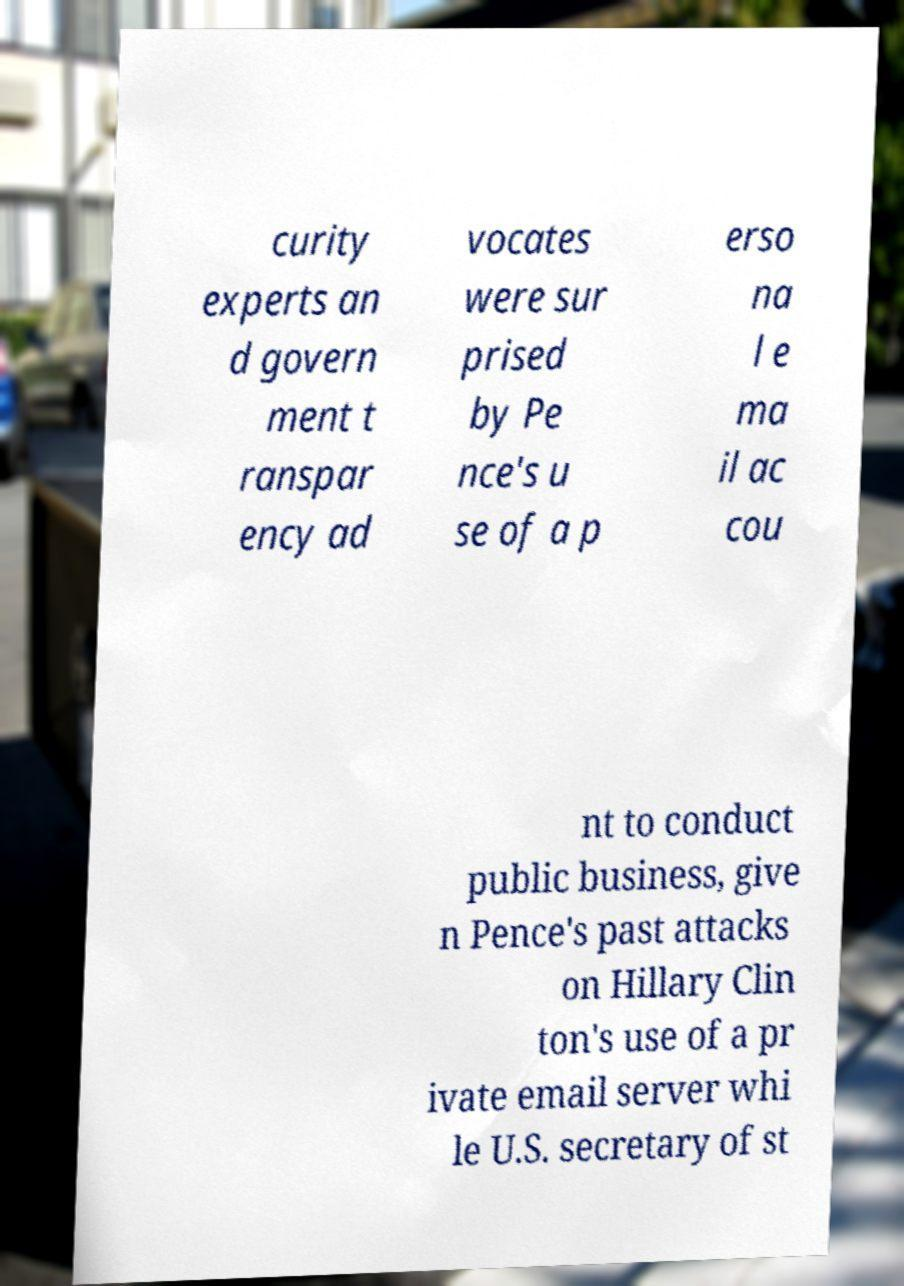Can you read and provide the text displayed in the image?This photo seems to have some interesting text. Can you extract and type it out for me? curity experts an d govern ment t ranspar ency ad vocates were sur prised by Pe nce's u se of a p erso na l e ma il ac cou nt to conduct public business, give n Pence's past attacks on Hillary Clin ton's use of a pr ivate email server whi le U.S. secretary of st 